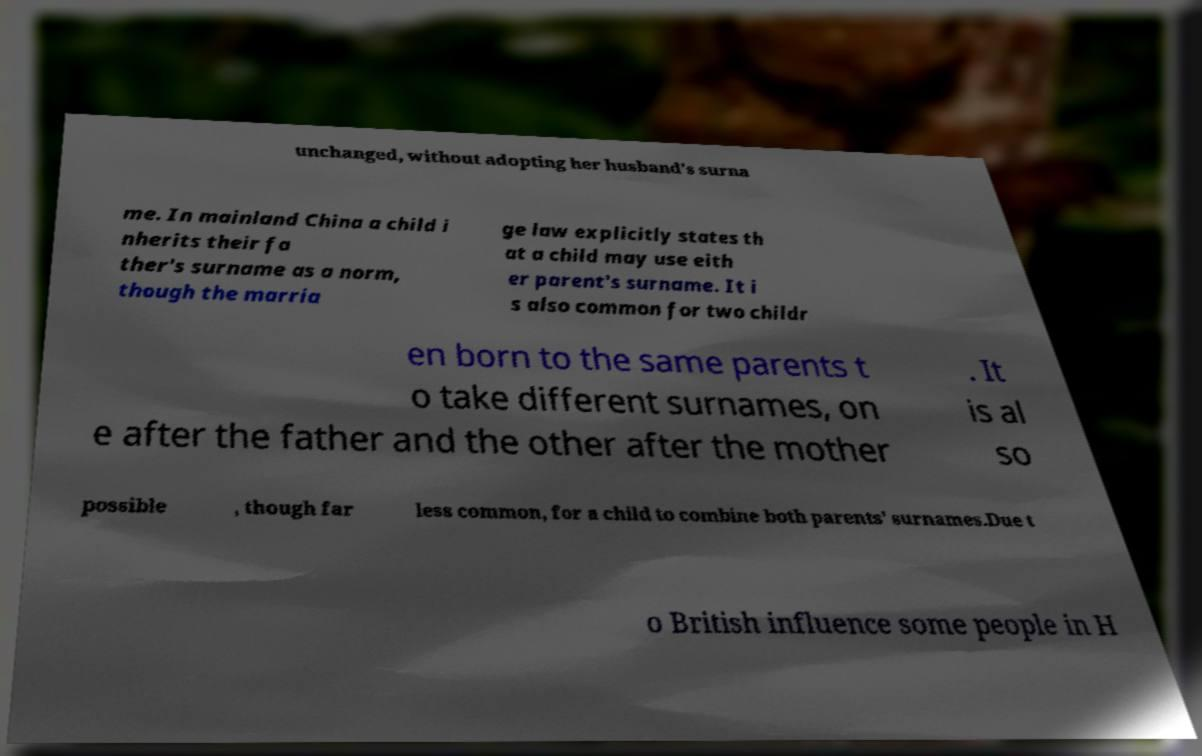I need the written content from this picture converted into text. Can you do that? unchanged, without adopting her husband's surna me. In mainland China a child i nherits their fa ther's surname as a norm, though the marria ge law explicitly states th at a child may use eith er parent's surname. It i s also common for two childr en born to the same parents t o take different surnames, on e after the father and the other after the mother . It is al so possible , though far less common, for a child to combine both parents' surnames.Due t o British influence some people in H 